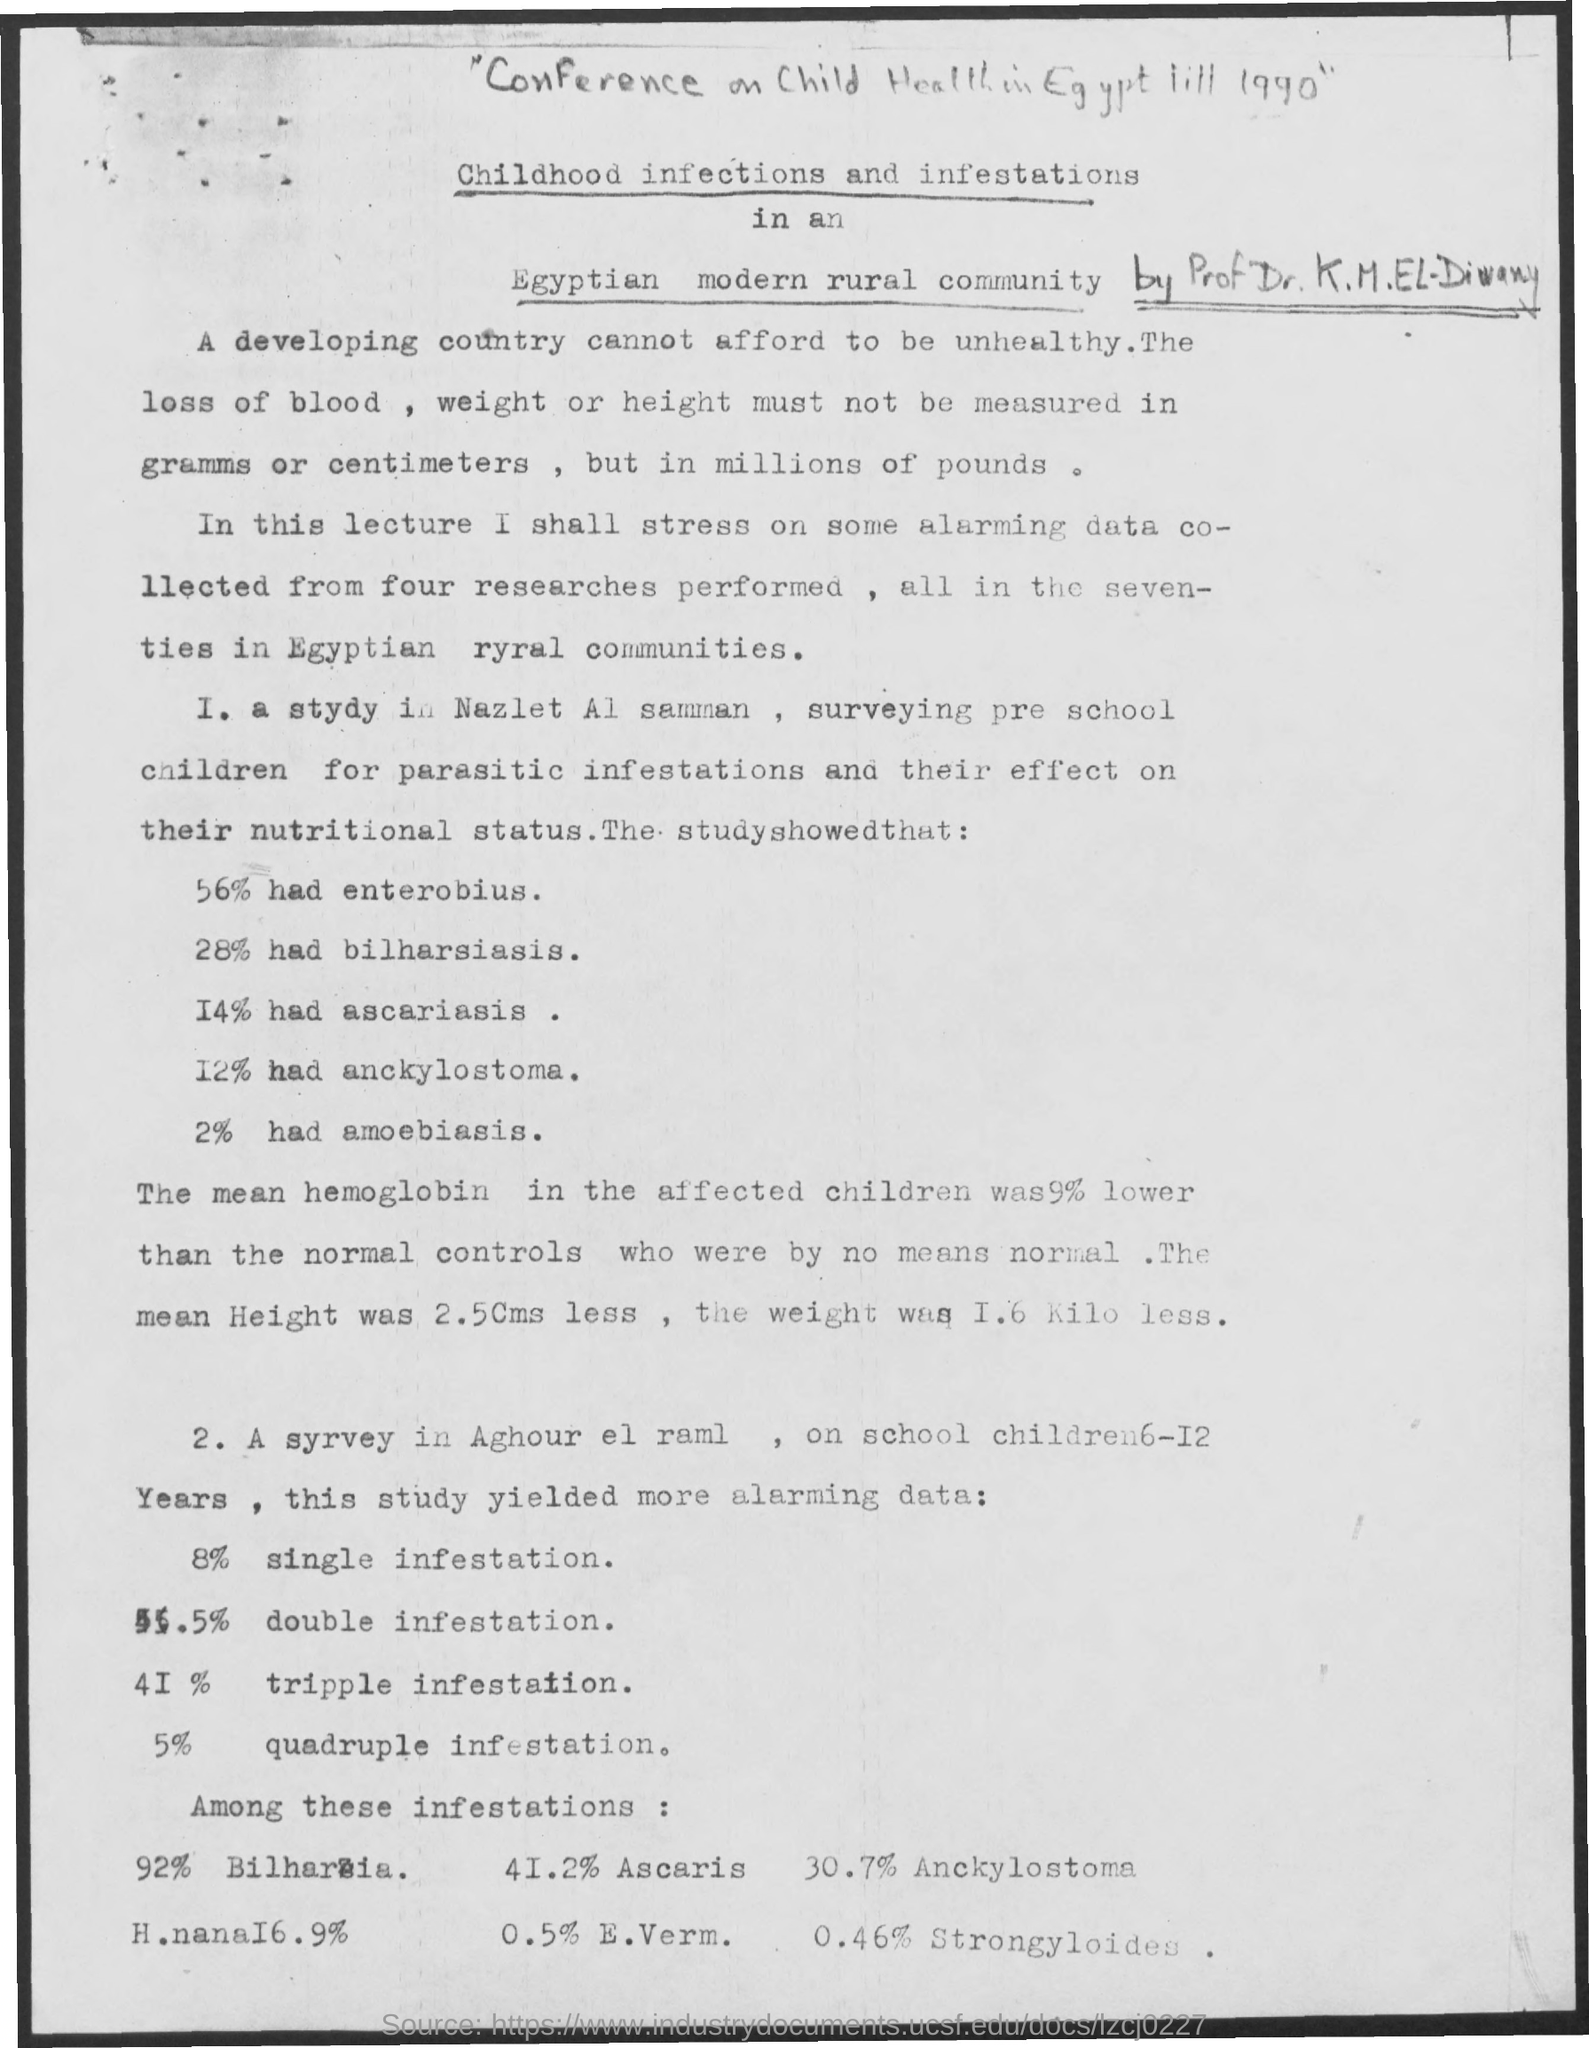Highlight a few significant elements in this photo. 56% of the participants had Enterobius. In the study, 41.2% of the participants had Ascaris. Approximately 14% of the individuals in the study had ascariasis, a parasitic infection caused by the roundworm Ascaris lumbricoides. According to the study, 28% of the individuals tested positive for bilharsiasis. Approximately 5% of the individuals in the study had a quadruple infection. 